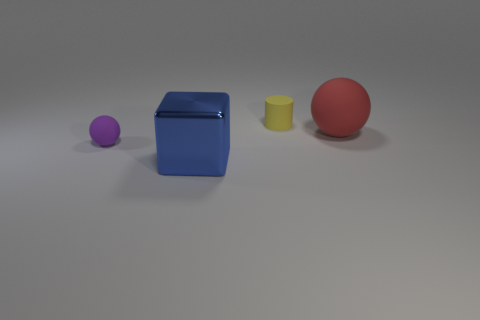Add 3 small blue rubber things. How many objects exist? 7 Subtract 1 balls. How many balls are left? 1 Subtract all blue blocks. Subtract all big yellow rubber things. How many objects are left? 3 Add 2 small purple rubber things. How many small purple rubber things are left? 3 Add 1 large shiny objects. How many large shiny objects exist? 2 Subtract all red spheres. How many spheres are left? 1 Subtract 0 red cylinders. How many objects are left? 4 Subtract all cylinders. How many objects are left? 3 Subtract all cyan blocks. Subtract all purple cylinders. How many blocks are left? 1 